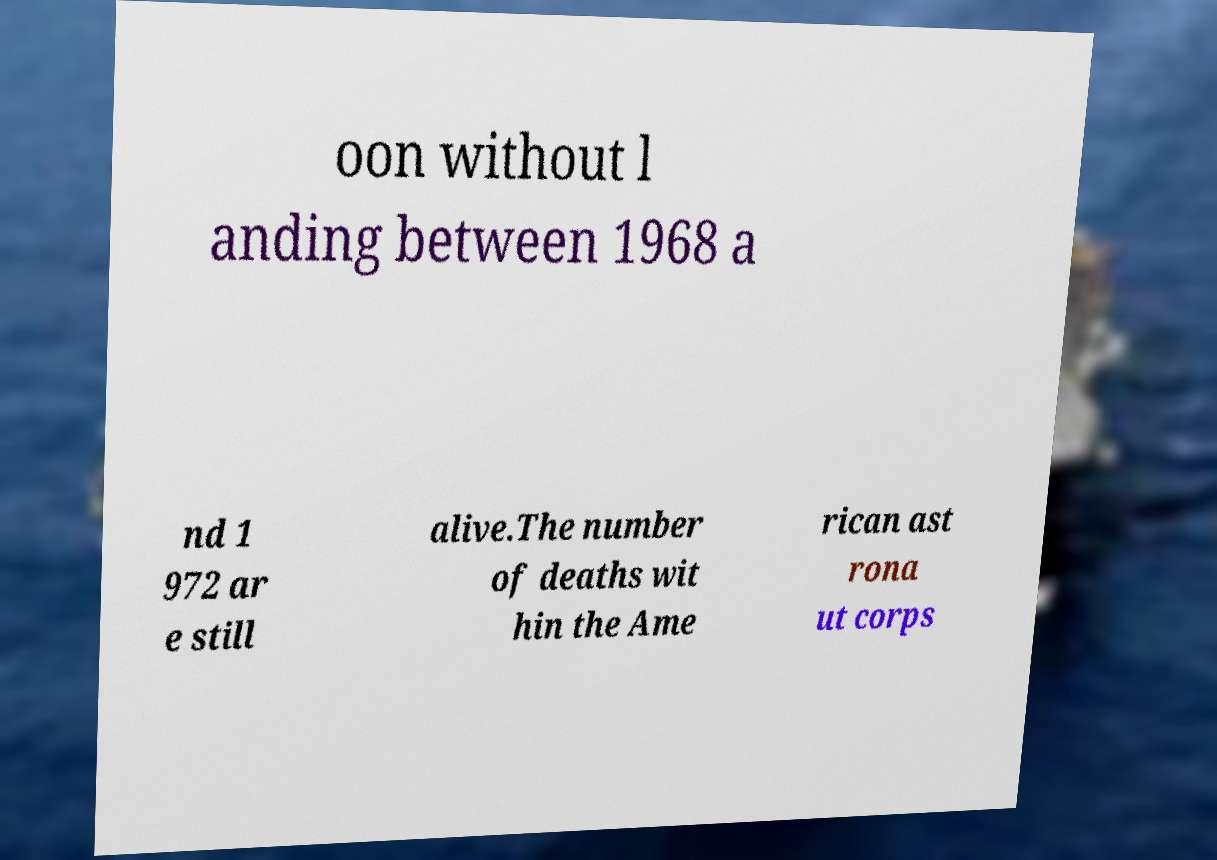Please read and relay the text visible in this image. What does it say? oon without l anding between 1968 a nd 1 972 ar e still alive.The number of deaths wit hin the Ame rican ast rona ut corps 